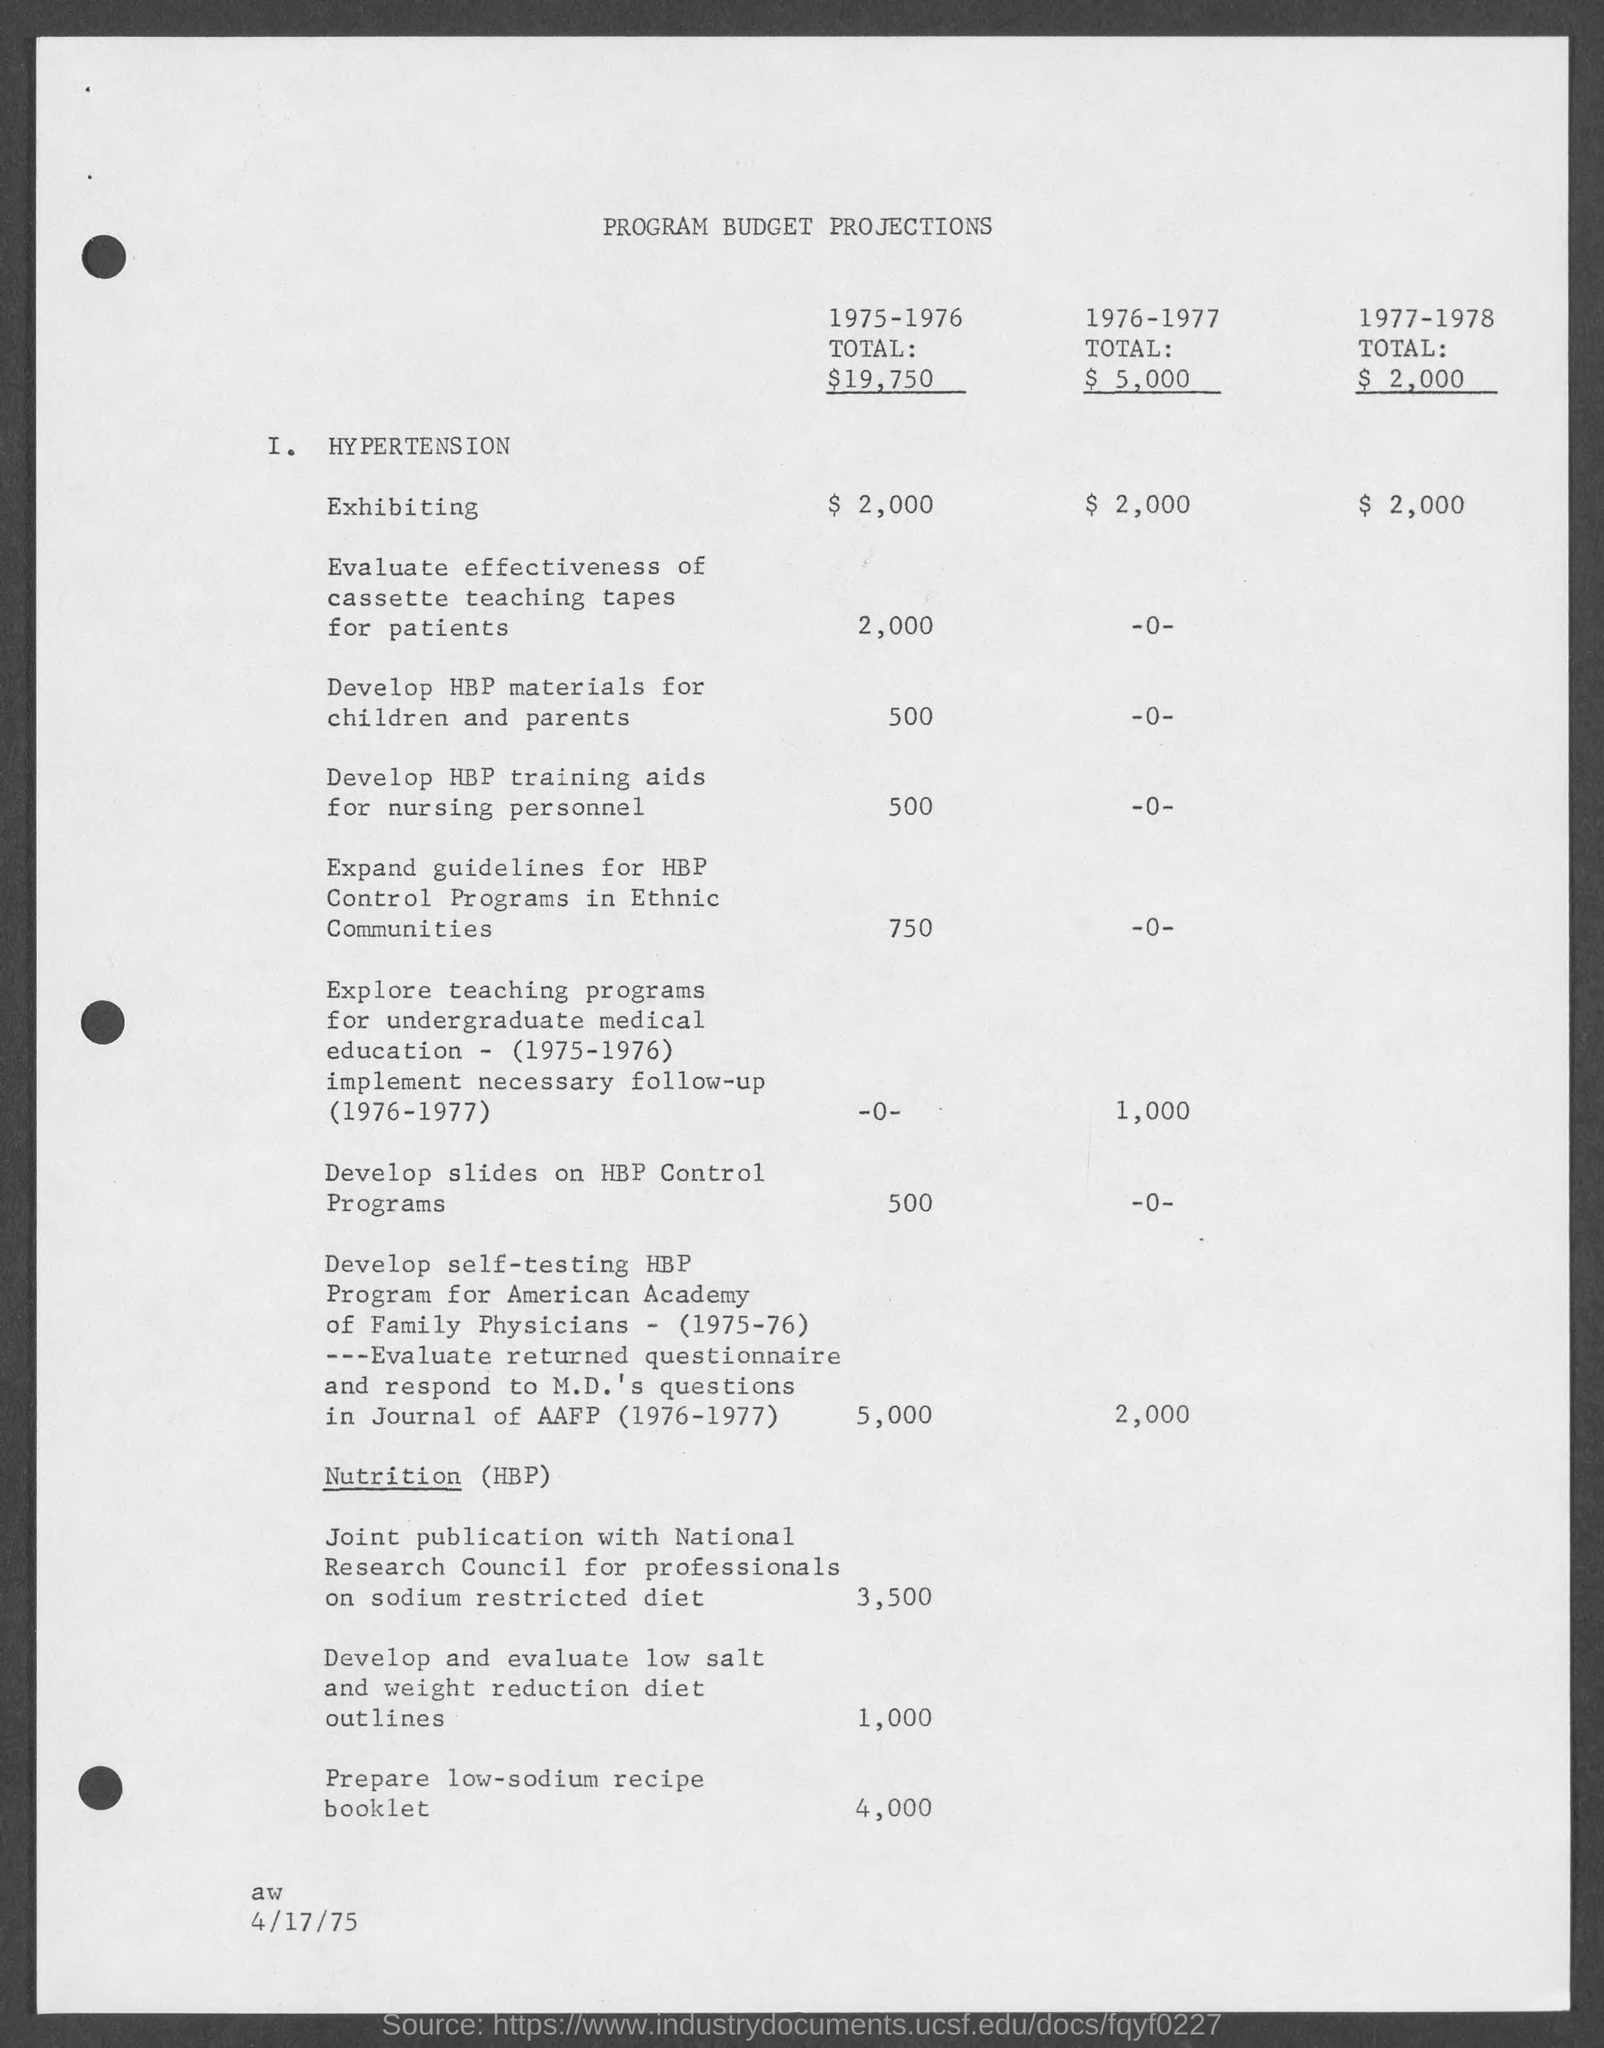What is the title of page?
Give a very brief answer. PROGRAM BUDGET PROJECTIONS. What is the total in 1975-1976?
Provide a short and direct response. $ 19,750. What is the total in 1976-1977?
Your answer should be compact. $ 5,000. What is the total in 1977-1978?
Give a very brief answer. $ 2,000. What is the date at bottom of the page?
Offer a terse response. 4/17/75. 